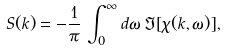<formula> <loc_0><loc_0><loc_500><loc_500>S ( k ) = - \frac { 1 } { \pi } \, \int ^ { \infty } _ { 0 } d \omega \, \Im [ \chi ( k , \omega ) ] ,</formula> 